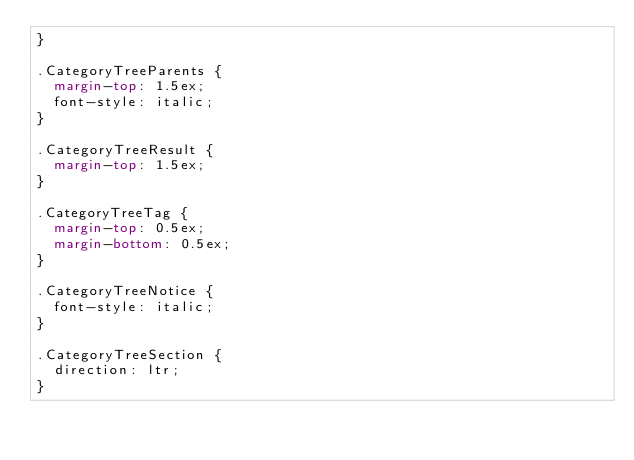Convert code to text. <code><loc_0><loc_0><loc_500><loc_500><_CSS_>}

.CategoryTreeParents {
	margin-top: 1.5ex;
	font-style: italic;
}

.CategoryTreeResult {
	margin-top: 1.5ex;
}

.CategoryTreeTag {
	margin-top: 0.5ex;
	margin-bottom: 0.5ex;
}

.CategoryTreeNotice {
	font-style: italic;
}

.CategoryTreeSection {
	direction: ltr;
}
</code> 